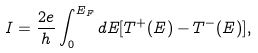<formula> <loc_0><loc_0><loc_500><loc_500>I = \frac { 2 e } { h } \int _ { 0 } ^ { E _ { F } } d E [ T ^ { + } ( E ) - T ^ { - } ( E ) ] ,</formula> 